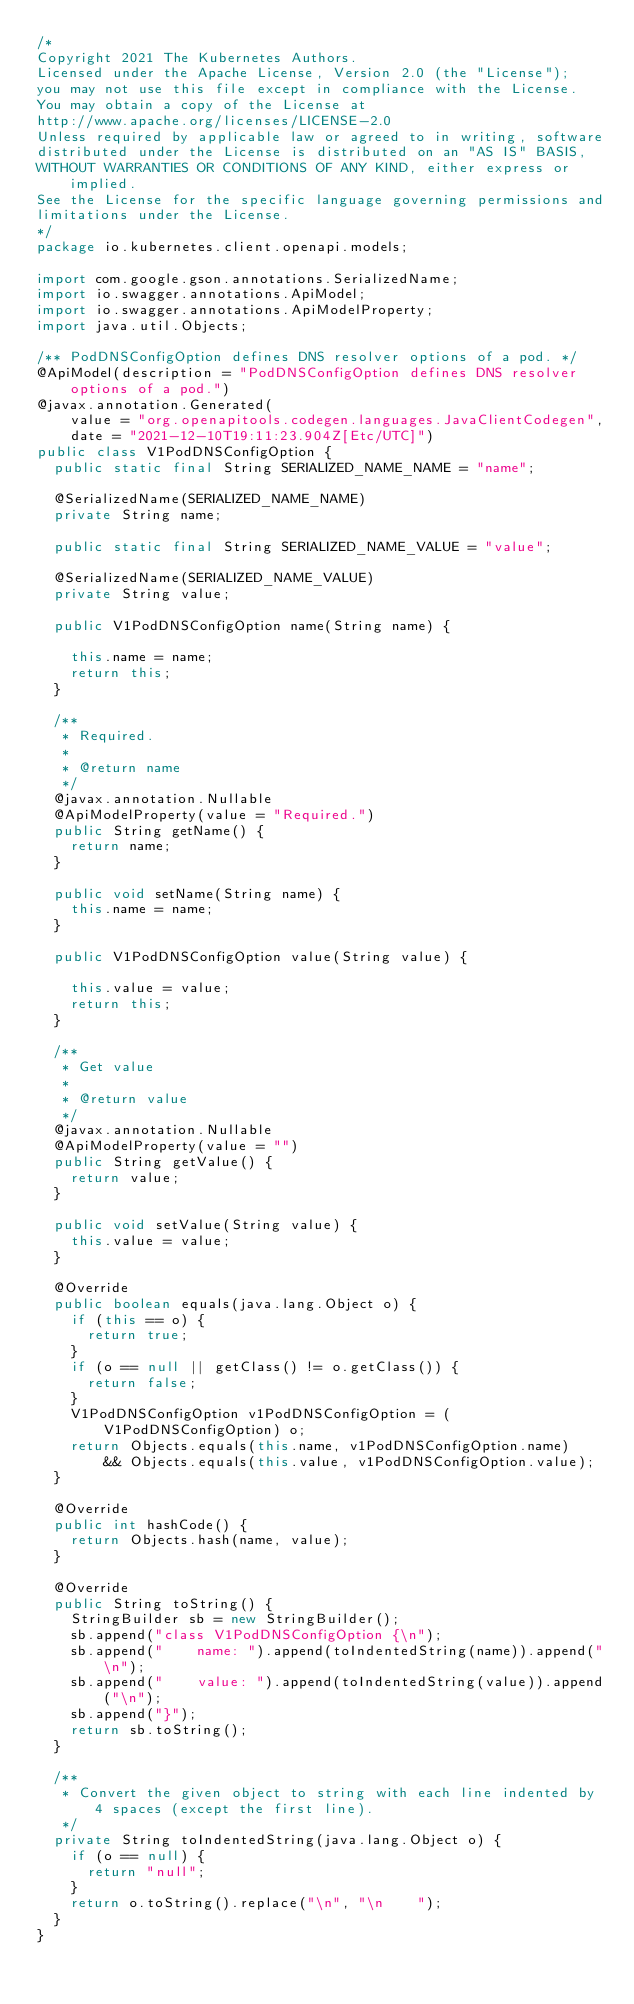<code> <loc_0><loc_0><loc_500><loc_500><_Java_>/*
Copyright 2021 The Kubernetes Authors.
Licensed under the Apache License, Version 2.0 (the "License");
you may not use this file except in compliance with the License.
You may obtain a copy of the License at
http://www.apache.org/licenses/LICENSE-2.0
Unless required by applicable law or agreed to in writing, software
distributed under the License is distributed on an "AS IS" BASIS,
WITHOUT WARRANTIES OR CONDITIONS OF ANY KIND, either express or implied.
See the License for the specific language governing permissions and
limitations under the License.
*/
package io.kubernetes.client.openapi.models;

import com.google.gson.annotations.SerializedName;
import io.swagger.annotations.ApiModel;
import io.swagger.annotations.ApiModelProperty;
import java.util.Objects;

/** PodDNSConfigOption defines DNS resolver options of a pod. */
@ApiModel(description = "PodDNSConfigOption defines DNS resolver options of a pod.")
@javax.annotation.Generated(
    value = "org.openapitools.codegen.languages.JavaClientCodegen",
    date = "2021-12-10T19:11:23.904Z[Etc/UTC]")
public class V1PodDNSConfigOption {
  public static final String SERIALIZED_NAME_NAME = "name";

  @SerializedName(SERIALIZED_NAME_NAME)
  private String name;

  public static final String SERIALIZED_NAME_VALUE = "value";

  @SerializedName(SERIALIZED_NAME_VALUE)
  private String value;

  public V1PodDNSConfigOption name(String name) {

    this.name = name;
    return this;
  }

  /**
   * Required.
   *
   * @return name
   */
  @javax.annotation.Nullable
  @ApiModelProperty(value = "Required.")
  public String getName() {
    return name;
  }

  public void setName(String name) {
    this.name = name;
  }

  public V1PodDNSConfigOption value(String value) {

    this.value = value;
    return this;
  }

  /**
   * Get value
   *
   * @return value
   */
  @javax.annotation.Nullable
  @ApiModelProperty(value = "")
  public String getValue() {
    return value;
  }

  public void setValue(String value) {
    this.value = value;
  }

  @Override
  public boolean equals(java.lang.Object o) {
    if (this == o) {
      return true;
    }
    if (o == null || getClass() != o.getClass()) {
      return false;
    }
    V1PodDNSConfigOption v1PodDNSConfigOption = (V1PodDNSConfigOption) o;
    return Objects.equals(this.name, v1PodDNSConfigOption.name)
        && Objects.equals(this.value, v1PodDNSConfigOption.value);
  }

  @Override
  public int hashCode() {
    return Objects.hash(name, value);
  }

  @Override
  public String toString() {
    StringBuilder sb = new StringBuilder();
    sb.append("class V1PodDNSConfigOption {\n");
    sb.append("    name: ").append(toIndentedString(name)).append("\n");
    sb.append("    value: ").append(toIndentedString(value)).append("\n");
    sb.append("}");
    return sb.toString();
  }

  /**
   * Convert the given object to string with each line indented by 4 spaces (except the first line).
   */
  private String toIndentedString(java.lang.Object o) {
    if (o == null) {
      return "null";
    }
    return o.toString().replace("\n", "\n    ");
  }
}
</code> 